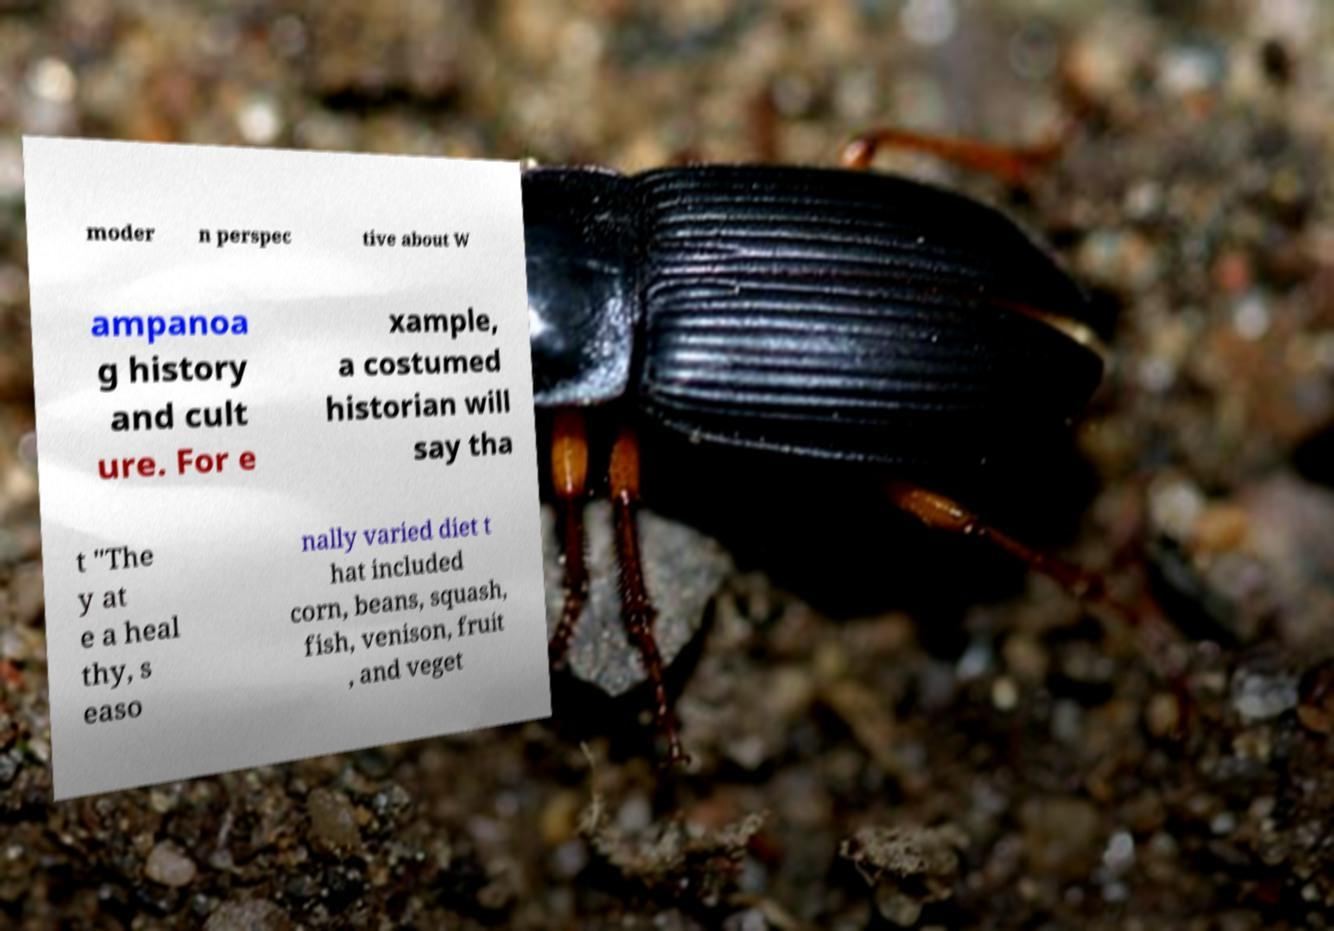Please read and relay the text visible in this image. What does it say? moder n perspec tive about W ampanoa g history and cult ure. For e xample, a costumed historian will say tha t "The y at e a heal thy, s easo nally varied diet t hat included corn, beans, squash, fish, venison, fruit , and veget 